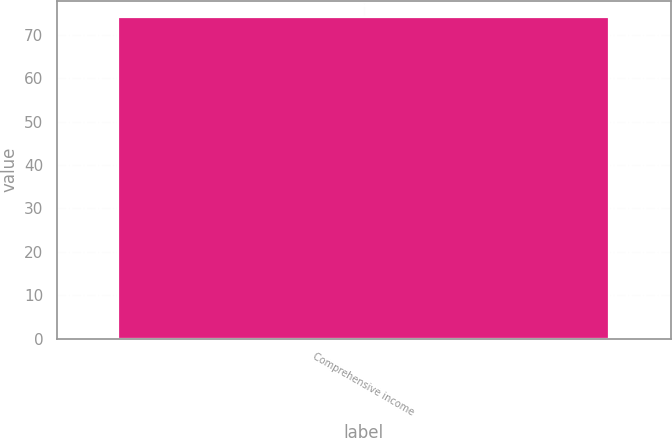<chart> <loc_0><loc_0><loc_500><loc_500><bar_chart><fcel>Comprehensive income<nl><fcel>74.1<nl></chart> 